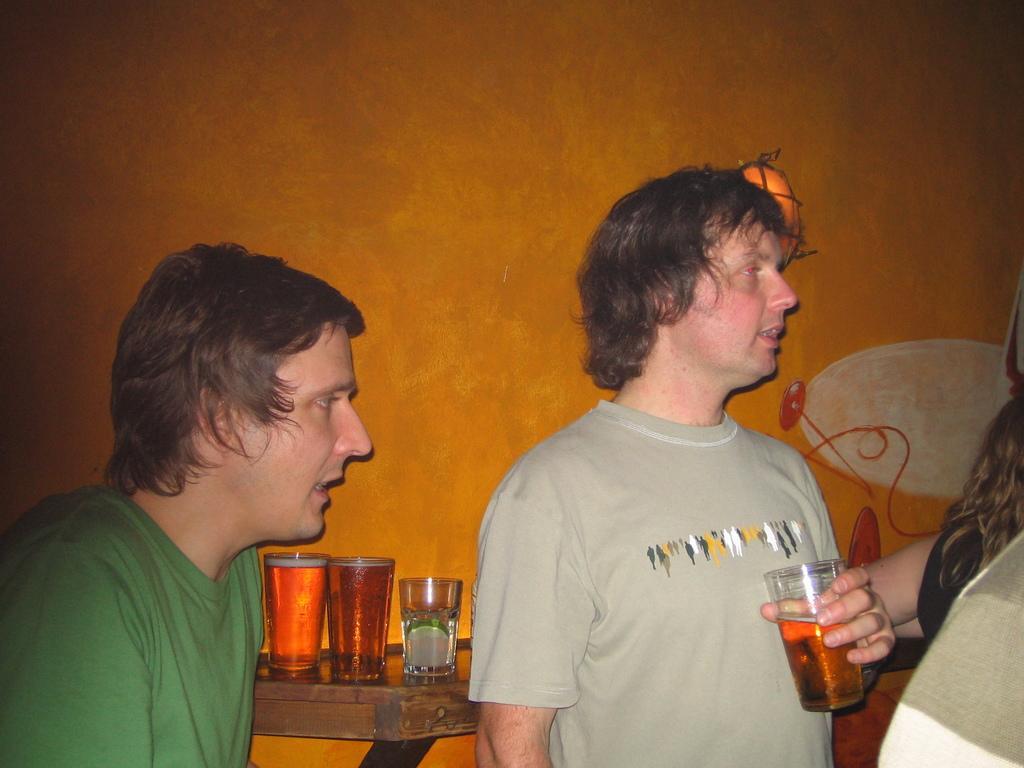Describe this image in one or two sentences. As we can see in the image there orange color wall, few people standing over here and there is a table. On table there are three glasses. 